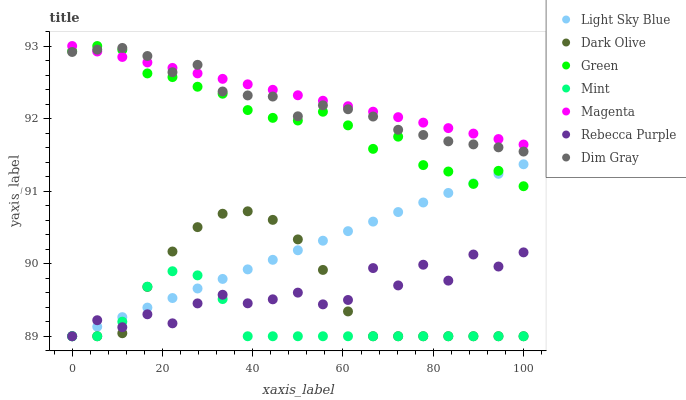Does Mint have the minimum area under the curve?
Answer yes or no. Yes. Does Magenta have the maximum area under the curve?
Answer yes or no. Yes. Does Dark Olive have the minimum area under the curve?
Answer yes or no. No. Does Dark Olive have the maximum area under the curve?
Answer yes or no. No. Is Light Sky Blue the smoothest?
Answer yes or no. Yes. Is Rebecca Purple the roughest?
Answer yes or no. Yes. Is Dark Olive the smoothest?
Answer yes or no. No. Is Dark Olive the roughest?
Answer yes or no. No. Does Dark Olive have the lowest value?
Answer yes or no. Yes. Does Green have the lowest value?
Answer yes or no. No. Does Magenta have the highest value?
Answer yes or no. Yes. Does Dark Olive have the highest value?
Answer yes or no. No. Is Mint less than Magenta?
Answer yes or no. Yes. Is Dim Gray greater than Mint?
Answer yes or no. Yes. Does Rebecca Purple intersect Mint?
Answer yes or no. Yes. Is Rebecca Purple less than Mint?
Answer yes or no. No. Is Rebecca Purple greater than Mint?
Answer yes or no. No. Does Mint intersect Magenta?
Answer yes or no. No. 